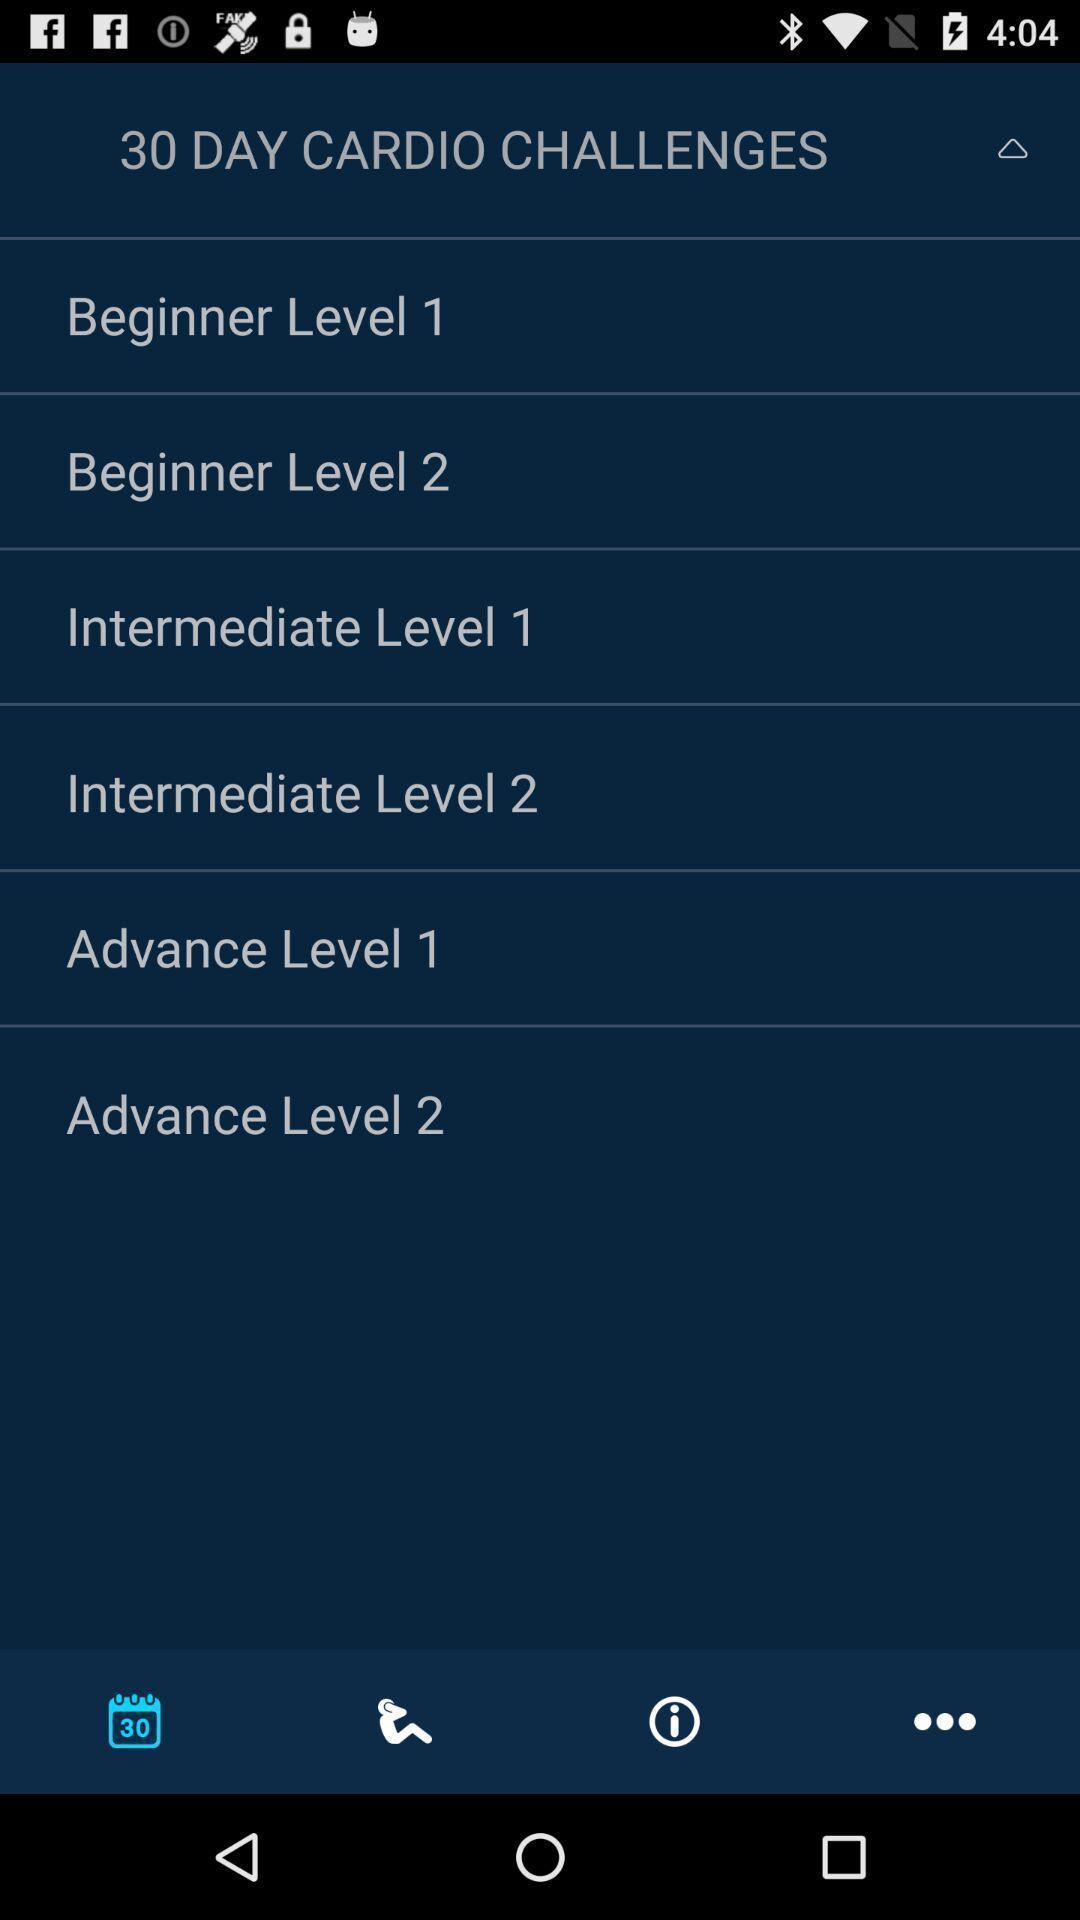Give me a narrative description of this picture. Various workout levels displayed of a fitness training app. 